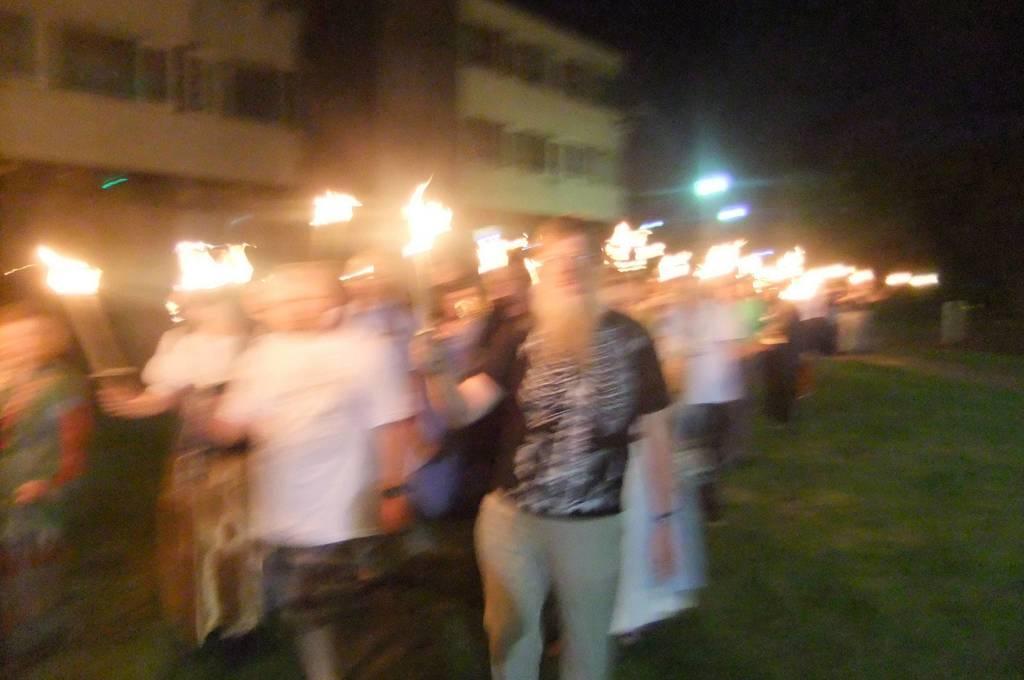In one or two sentences, can you explain what this image depicts? In this picture there is a group of men and women standing in the front and holding the fire stick in the hand. Behind there is a white building. 